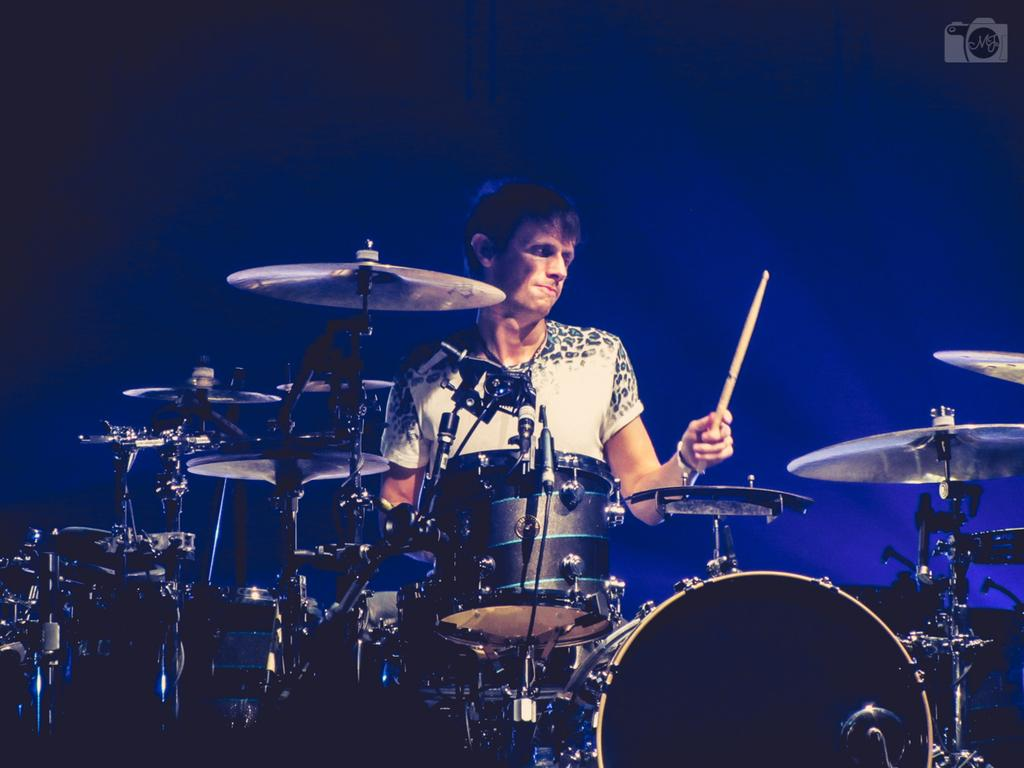What is the overall appearance of the background in the image? The background of the image is very dark. Can you describe the person in the image? There is a man in the image. What is the man doing in the image? The man is playing drums. What is the man holding in his hand? The man is holding a stick in his hand. What other musical instrument can be seen in the image? There is a cymbal in the image. What type of air is being used to power the man's drumming in the image? There is no indication of any air being used to power the man's drumming in the image. What type of voyage is the man embarking on while playing the drums in the image? There is no indication of any voyage in the image; the man is simply playing drums. 